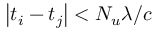Convert formula to latex. <formula><loc_0><loc_0><loc_500><loc_500>\left | t _ { i } - t _ { j } \right | < N _ { u } \lambda / c</formula> 